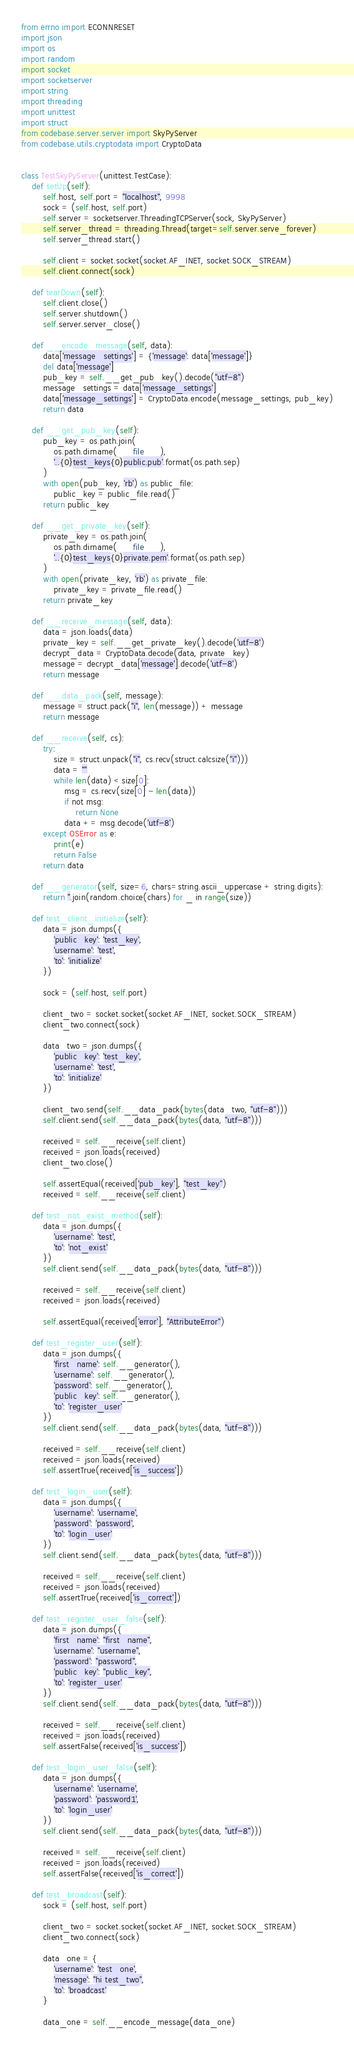<code> <loc_0><loc_0><loc_500><loc_500><_Python_>from errno import ECONNRESET
import json
import os
import random
import socket
import socketserver
import string
import threading
import unittest
import struct
from codebase.server.server import SkyPyServer
from codebase.utils.cryptodata import CryptoData


class TestSkyPyServer(unittest.TestCase):
    def setUp(self):
        self.host, self.port = "localhost", 9998
        sock = (self.host, self.port)
        self.server = socketserver.ThreadingTCPServer(sock, SkyPyServer)
        self.server_thread = threading.Thread(target=self.server.serve_forever)
        self.server_thread.start()

        self.client = socket.socket(socket.AF_INET, socket.SOCK_STREAM)
        self.client.connect(sock)

    def tearDown(self):
        self.client.close()
        self.server.shutdown()
        self.server.server_close()

    def __encode_message(self, data):
        data['message_settings'] = {'message': data['message']}
        del data['message']
        pub_key = self.__get_pub_key().decode("utf-8")
        message_settings = data['message_settings']
        data['message_settings'] = CryptoData.encode(message_settings, pub_key)
        return data

    def __get_pub_key(self):
        pub_key = os.path.join(
            os.path.dirname(__file__),
            '..{0}test_keys{0}public.pub'.format(os.path.sep)
        )
        with open(pub_key, 'rb') as public_file:
            public_key = public_file.read()
        return public_key

    def __get_private_key(self):
        private_key = os.path.join(
            os.path.dirname(__file__),
            '..{0}test_keys{0}private.pem'.format(os.path.sep)
        )
        with open(private_key, 'rb') as private_file:
            private_key = private_file.read()
        return private_key

    def __receive_message(self, data):
        data = json.loads(data)
        private_key = self.__get_private_key().decode('utf-8')
        decrypt_data = CryptoData.decode(data, private_key)
        message = decrypt_data['message'].decode('utf-8')
        return message

    def __data_pack(self, message):
        message = struct.pack("i", len(message)) + message
        return message

    def __receive(self, cs):
        try:
            size = struct.unpack("i", cs.recv(struct.calcsize("i")))
            data = ""
            while len(data) < size[0]:
                msg = cs.recv(size[0] - len(data))
                if not msg:
                    return None
                data += msg.decode('utf-8')
        except OSError as e:
            print(e)
            return False
        return data

    def __generator(self, size=6, chars=string.ascii_uppercase + string.digits):
        return ''.join(random.choice(chars) for _ in range(size))

    def test_client_initialize(self):
        data = json.dumps({
            'public_key': 'test_key',
            'username': 'test',
            'to': 'initialize'
        })

        sock = (self.host, self.port)

        client_two = socket.socket(socket.AF_INET, socket.SOCK_STREAM)
        client_two.connect(sock)

        data_two = json.dumps({
            'public_key': 'test_key',
            'username': 'test',
            'to': 'initialize'
        })

        client_two.send(self.__data_pack(bytes(data_two, "utf-8")))
        self.client.send(self.__data_pack(bytes(data, "utf-8")))

        received = self.__receive(self.client)
        received = json.loads(received)
        client_two.close()

        self.assertEqual(received['pub_key'], "test_key")
        received = self.__receive(self.client)

    def test_not_exist_method(self):
        data = json.dumps({
            'username': 'test',
            'to': 'not_exist'
        })
        self.client.send(self.__data_pack(bytes(data, "utf-8")))

        received = self.__receive(self.client)
        received = json.loads(received)

        self.assertEqual(received['error'], "AttributeError")

    def test_register_user(self):
        data = json.dumps({
            'first_name': self.__generator(),
            'username': self.__generator(),
            'password': self.__generator(),
            'public_key': self.__generator(),
            'to': 'register_user'
        })
        self.client.send(self.__data_pack(bytes(data, "utf-8")))

        received = self.__receive(self.client)
        received = json.loads(received)
        self.assertTrue(received['is_success'])

    def test_login_user(self):
        data = json.dumps({
            'username': 'username',
            'password': 'password',
            'to': 'login_user'
        })
        self.client.send(self.__data_pack(bytes(data, "utf-8")))

        received = self.__receive(self.client)
        received = json.loads(received)
        self.assertTrue(received['is_correct'])

    def test_register_user_false(self):
        data = json.dumps({
            'first_name': "first_name",
            'username': "username",
            'password': "password",
            'public_key': "public_key",
            'to': 'register_user'
        })
        self.client.send(self.__data_pack(bytes(data, "utf-8")))

        received = self.__receive(self.client)
        received = json.loads(received)
        self.assertFalse(received['is_success'])

    def test_login_user_false(self):
        data = json.dumps({
            'username': 'username',
            'password': 'password1',
            'to': 'login_user'
        })
        self.client.send(self.__data_pack(bytes(data, "utf-8")))

        received = self.__receive(self.client)
        received = json.loads(received)
        self.assertFalse(received['is_correct'])

    def test_broadcast(self):
        sock = (self.host, self.port)

        client_two = socket.socket(socket.AF_INET, socket.SOCK_STREAM)
        client_two.connect(sock)

        data_one = {
            'username': 'test_one',
            'message': "hi test_two",
            'to': 'broadcast'
        }

        data_one = self.__encode_message(data_one)</code> 